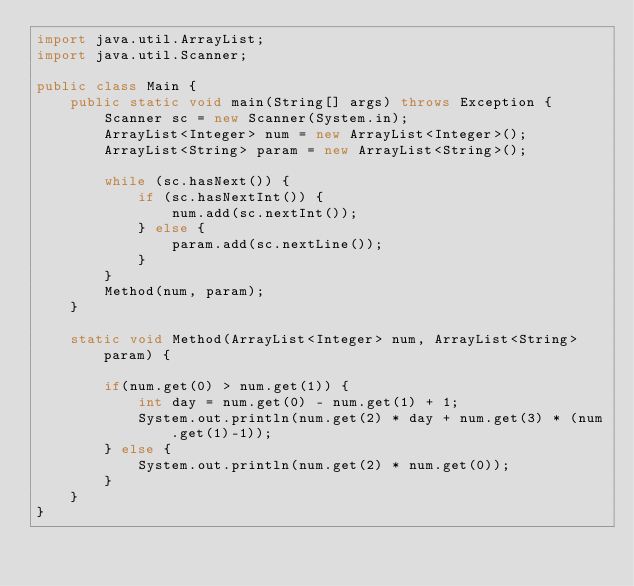<code> <loc_0><loc_0><loc_500><loc_500><_Java_>import java.util.ArrayList;
import java.util.Scanner;

public class Main {
	public static void main(String[] args) throws Exception {
		Scanner sc = new Scanner(System.in);
		ArrayList<Integer> num = new ArrayList<Integer>();
		ArrayList<String> param = new ArrayList<String>();

		while (sc.hasNext()) {
			if (sc.hasNextInt()) {
				num.add(sc.nextInt());
			} else {
				param.add(sc.nextLine());
			}
		}
		Method(num, param);
	}
	
	static void Method(ArrayList<Integer> num, ArrayList<String> param) {

		if(num.get(0) > num.get(1)) {
			int day = num.get(0) - num.get(1) + 1;
			System.out.println(num.get(2) * day + num.get(3) * (num.get(1)-1));
		} else {
			System.out.println(num.get(2) * num.get(0));
		}
	}
}</code> 